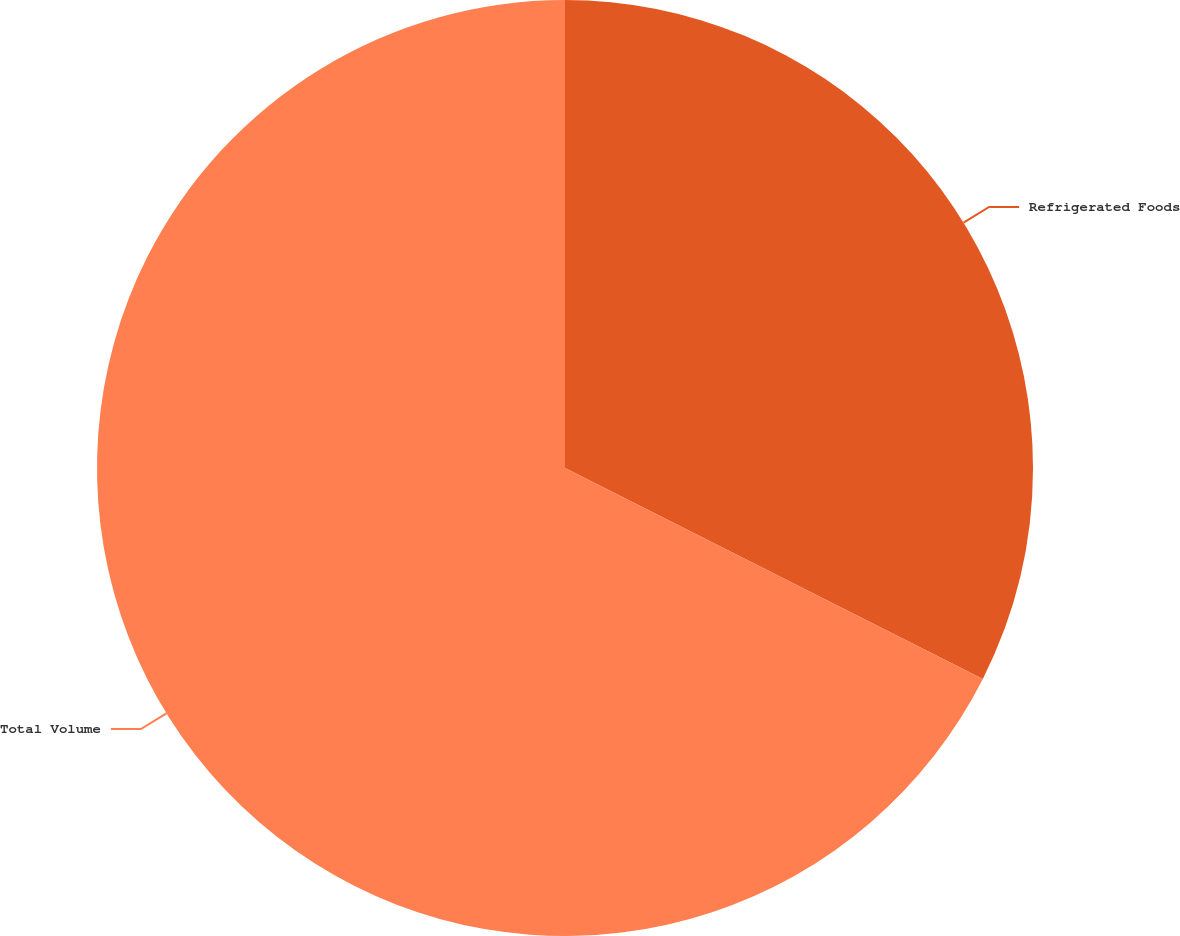<chart> <loc_0><loc_0><loc_500><loc_500><pie_chart><fcel>Refrigerated Foods<fcel>Total Volume<nl><fcel>32.44%<fcel>67.56%<nl></chart> 